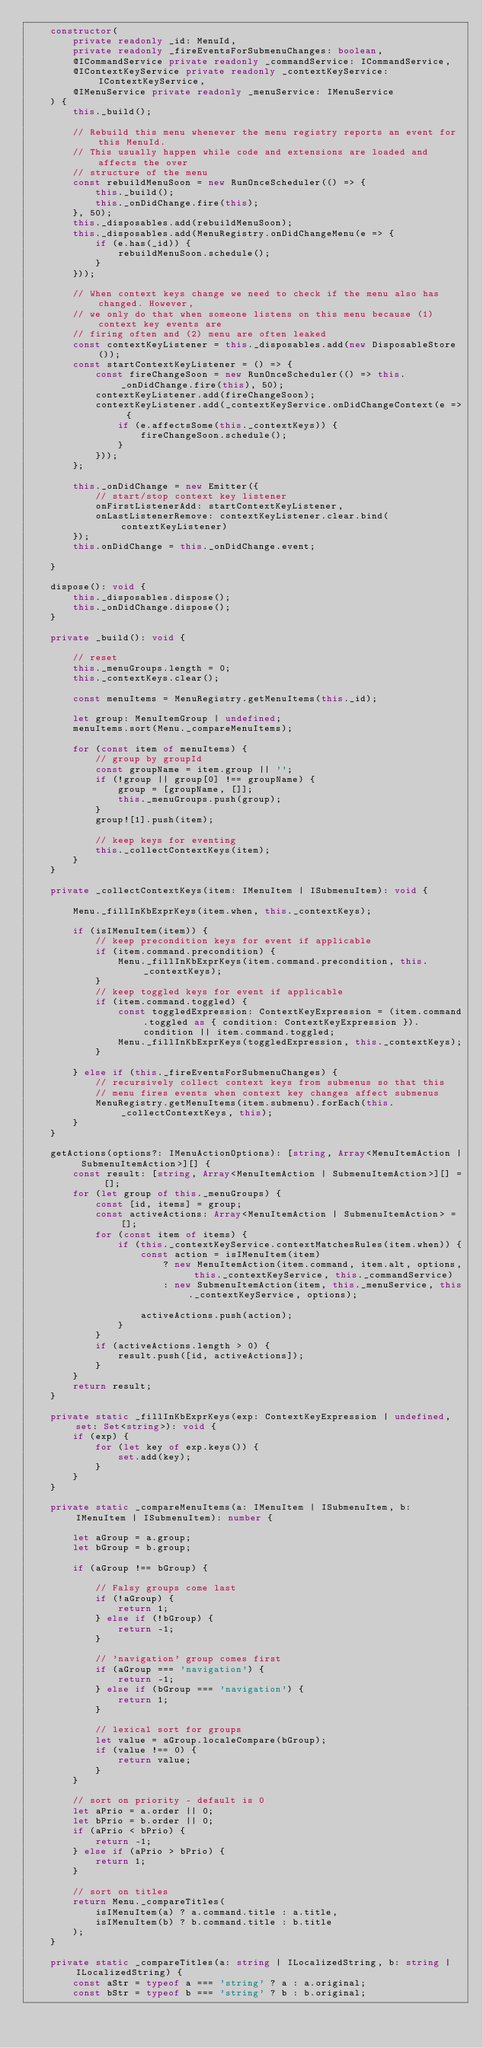Convert code to text. <code><loc_0><loc_0><loc_500><loc_500><_TypeScript_>	constructor(
		private readonly _id: MenuId,
		private readonly _fireEventsForSubmenuChanges: boolean,
		@ICommandService private readonly _commandService: ICommandService,
		@IContextKeyService private readonly _contextKeyService: IContextKeyService,
		@IMenuService private readonly _menuService: IMenuService
	) {
		this._build();

		// Rebuild this menu whenever the menu registry reports an event for this MenuId.
		// This usually happen while code and extensions are loaded and affects the over
		// structure of the menu
		const rebuildMenuSoon = new RunOnceScheduler(() => {
			this._build();
			this._onDidChange.fire(this);
		}, 50);
		this._disposables.add(rebuildMenuSoon);
		this._disposables.add(MenuRegistry.onDidChangeMenu(e => {
			if (e.has(_id)) {
				rebuildMenuSoon.schedule();
			}
		}));

		// When context keys change we need to check if the menu also has changed. However,
		// we only do that when someone listens on this menu because (1) context key events are
		// firing often and (2) menu are often leaked
		const contextKeyListener = this._disposables.add(new DisposableStore());
		const startContextKeyListener = () => {
			const fireChangeSoon = new RunOnceScheduler(() => this._onDidChange.fire(this), 50);
			contextKeyListener.add(fireChangeSoon);
			contextKeyListener.add(_contextKeyService.onDidChangeContext(e => {
				if (e.affectsSome(this._contextKeys)) {
					fireChangeSoon.schedule();
				}
			}));
		};

		this._onDidChange = new Emitter({
			// start/stop context key listener
			onFirstListenerAdd: startContextKeyListener,
			onLastListenerRemove: contextKeyListener.clear.bind(contextKeyListener)
		});
		this.onDidChange = this._onDidChange.event;

	}

	dispose(): void {
		this._disposables.dispose();
		this._onDidChange.dispose();
	}

	private _build(): void {

		// reset
		this._menuGroups.length = 0;
		this._contextKeys.clear();

		const menuItems = MenuRegistry.getMenuItems(this._id);

		let group: MenuItemGroup | undefined;
		menuItems.sort(Menu._compareMenuItems);

		for (const item of menuItems) {
			// group by groupId
			const groupName = item.group || '';
			if (!group || group[0] !== groupName) {
				group = [groupName, []];
				this._menuGroups.push(group);
			}
			group![1].push(item);

			// keep keys for eventing
			this._collectContextKeys(item);
		}
	}

	private _collectContextKeys(item: IMenuItem | ISubmenuItem): void {

		Menu._fillInKbExprKeys(item.when, this._contextKeys);

		if (isIMenuItem(item)) {
			// keep precondition keys for event if applicable
			if (item.command.precondition) {
				Menu._fillInKbExprKeys(item.command.precondition, this._contextKeys);
			}
			// keep toggled keys for event if applicable
			if (item.command.toggled) {
				const toggledExpression: ContextKeyExpression = (item.command.toggled as { condition: ContextKeyExpression }).condition || item.command.toggled;
				Menu._fillInKbExprKeys(toggledExpression, this._contextKeys);
			}

		} else if (this._fireEventsForSubmenuChanges) {
			// recursively collect context keys from submenus so that this
			// menu fires events when context key changes affect submenus
			MenuRegistry.getMenuItems(item.submenu).forEach(this._collectContextKeys, this);
		}
	}

	getActions(options?: IMenuActionOptions): [string, Array<MenuItemAction | SubmenuItemAction>][] {
		const result: [string, Array<MenuItemAction | SubmenuItemAction>][] = [];
		for (let group of this._menuGroups) {
			const [id, items] = group;
			const activeActions: Array<MenuItemAction | SubmenuItemAction> = [];
			for (const item of items) {
				if (this._contextKeyService.contextMatchesRules(item.when)) {
					const action = isIMenuItem(item)
						? new MenuItemAction(item.command, item.alt, options, this._contextKeyService, this._commandService)
						: new SubmenuItemAction(item, this._menuService, this._contextKeyService, options);

					activeActions.push(action);
				}
			}
			if (activeActions.length > 0) {
				result.push([id, activeActions]);
			}
		}
		return result;
	}

	private static _fillInKbExprKeys(exp: ContextKeyExpression | undefined, set: Set<string>): void {
		if (exp) {
			for (let key of exp.keys()) {
				set.add(key);
			}
		}
	}

	private static _compareMenuItems(a: IMenuItem | ISubmenuItem, b: IMenuItem | ISubmenuItem): number {

		let aGroup = a.group;
		let bGroup = b.group;

		if (aGroup !== bGroup) {

			// Falsy groups come last
			if (!aGroup) {
				return 1;
			} else if (!bGroup) {
				return -1;
			}

			// 'navigation' group comes first
			if (aGroup === 'navigation') {
				return -1;
			} else if (bGroup === 'navigation') {
				return 1;
			}

			// lexical sort for groups
			let value = aGroup.localeCompare(bGroup);
			if (value !== 0) {
				return value;
			}
		}

		// sort on priority - default is 0
		let aPrio = a.order || 0;
		let bPrio = b.order || 0;
		if (aPrio < bPrio) {
			return -1;
		} else if (aPrio > bPrio) {
			return 1;
		}

		// sort on titles
		return Menu._compareTitles(
			isIMenuItem(a) ? a.command.title : a.title,
			isIMenuItem(b) ? b.command.title : b.title
		);
	}

	private static _compareTitles(a: string | ILocalizedString, b: string | ILocalizedString) {
		const aStr = typeof a === 'string' ? a : a.original;
		const bStr = typeof b === 'string' ? b : b.original;</code> 